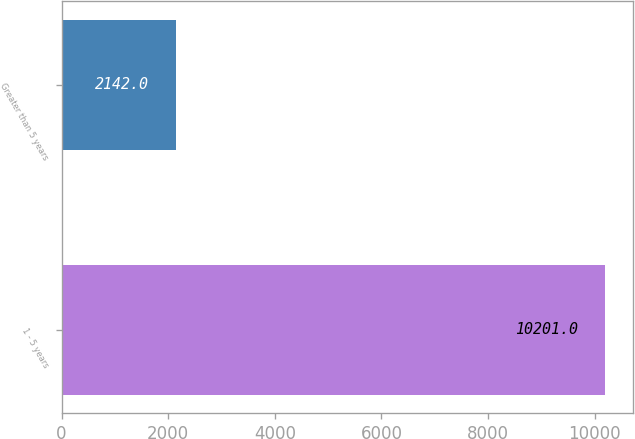<chart> <loc_0><loc_0><loc_500><loc_500><bar_chart><fcel>1 - 5 years<fcel>Greater than 5 years<nl><fcel>10201<fcel>2142<nl></chart> 